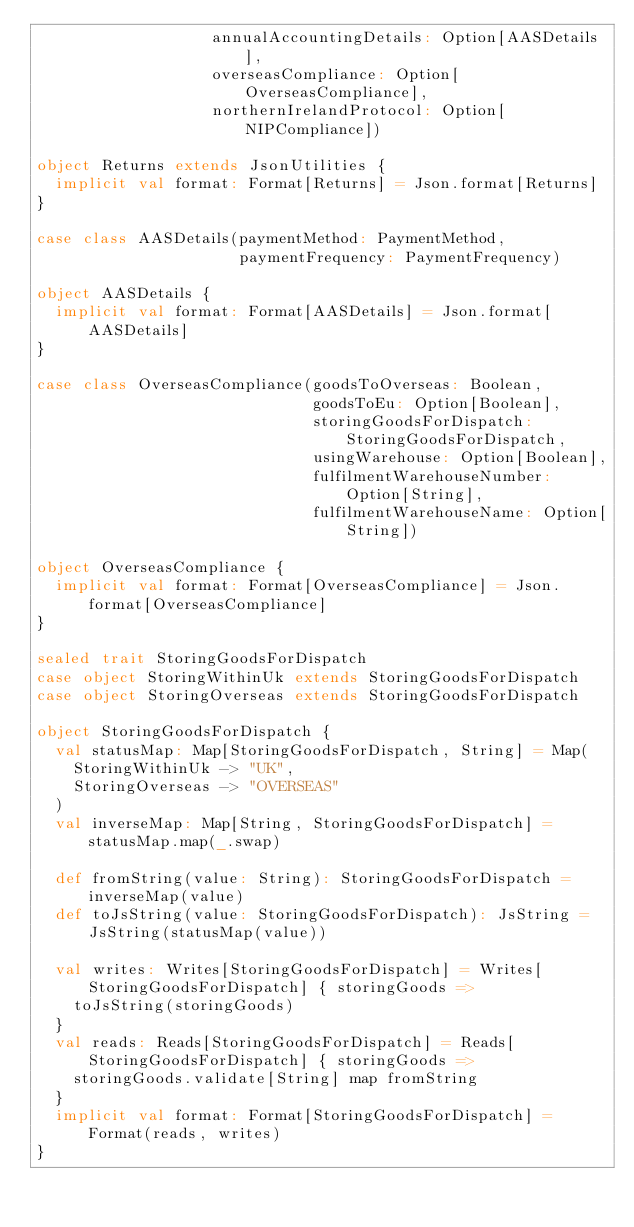<code> <loc_0><loc_0><loc_500><loc_500><_Scala_>                   annualAccountingDetails: Option[AASDetails],
                   overseasCompliance: Option[OverseasCompliance],
                   northernIrelandProtocol: Option[NIPCompliance])

object Returns extends JsonUtilities {
  implicit val format: Format[Returns] = Json.format[Returns]
}

case class AASDetails(paymentMethod: PaymentMethod,
                      paymentFrequency: PaymentFrequency)

object AASDetails {
  implicit val format: Format[AASDetails] = Json.format[AASDetails]
}

case class OverseasCompliance(goodsToOverseas: Boolean,
                              goodsToEu: Option[Boolean],
                              storingGoodsForDispatch: StoringGoodsForDispatch,
                              usingWarehouse: Option[Boolean],
                              fulfilmentWarehouseNumber: Option[String],
                              fulfilmentWarehouseName: Option[String])

object OverseasCompliance {
  implicit val format: Format[OverseasCompliance] = Json.format[OverseasCompliance]
}

sealed trait StoringGoodsForDispatch
case object StoringWithinUk extends StoringGoodsForDispatch
case object StoringOverseas extends StoringGoodsForDispatch

object StoringGoodsForDispatch {
  val statusMap: Map[StoringGoodsForDispatch, String] = Map(
    StoringWithinUk -> "UK",
    StoringOverseas -> "OVERSEAS"
  )
  val inverseMap: Map[String, StoringGoodsForDispatch] = statusMap.map(_.swap)

  def fromString(value: String): StoringGoodsForDispatch = inverseMap(value)
  def toJsString(value: StoringGoodsForDispatch): JsString = JsString(statusMap(value))

  val writes: Writes[StoringGoodsForDispatch] = Writes[StoringGoodsForDispatch] { storingGoods =>
    toJsString(storingGoods)
  }
  val reads: Reads[StoringGoodsForDispatch] = Reads[StoringGoodsForDispatch] { storingGoods =>
    storingGoods.validate[String] map fromString
  }
  implicit val format: Format[StoringGoodsForDispatch] = Format(reads, writes)
}</code> 